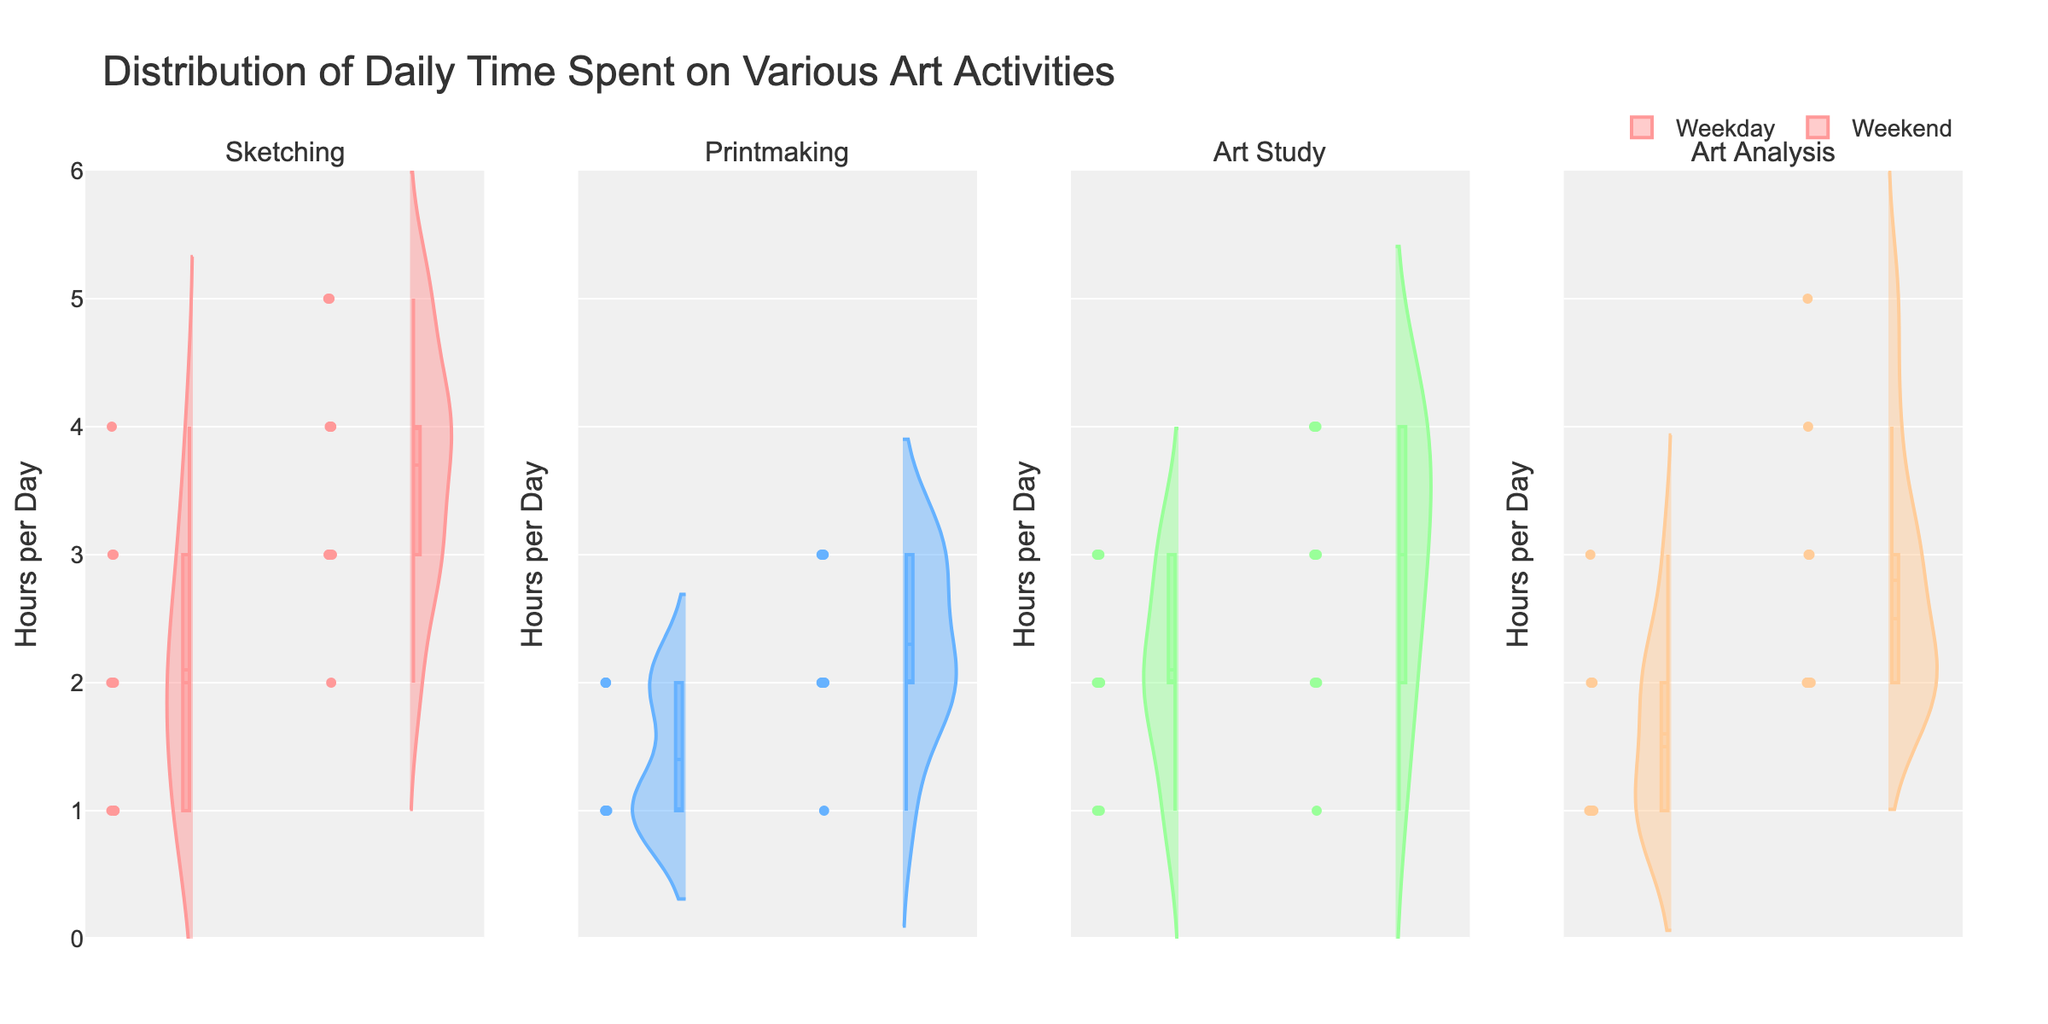whatisthetitleofthefigure The title is usually found at the top of the figure and it is clearly written in larger font.
Answer: Distribution of Daily Time Spent on Various Art Activities whichactivityhasthemostspreadinhoursonweekends To determine the spread, we look at the width of the violin plot. The wider it is, the more spread there is. Examining the violin plots, 'art_analysis' has the widest spread on weekends.
Answer: art analysis ontheweekdayswhichactivityhastheminimumvalueofhoursclosezero Look for the lowest point on the violin plots for each activity during the weekdays. 'art_analysis' shows a minimum close to zero hours.
Answer: art analysis whichactivityhasanoticeabledifferenceinmedianhoursbetweenweekdaysandweekends The median is indicated by a dashed line inside each violin plot. 'art_study' shows a noticeable difference between the weekday and weekend medians.
Answer: art study whatarethepossiblevaluesforthehoursperspentonsketchingduringweekdays The violin plot for 'sketching' on weekdays shows the spread of values. Based on the plot, the possible values range from 1 to 4 hours.
Answer: 1 to 4 hours howdothemedianhoursforsketchingduringweekdayscomparewiththeweekends Check the dashed line that represents the median for 'sketching' on both weekdays and weekends. Weekdays have a median around 2 hours, while weekends have a median around 4.
Answer: Weekends have a higher median howmanyhoursarecommonlyspentonprintmakingonweekends Observe the width and density of the violin plot for 'printmaking' on weekends. The densest region indicates common hours spent. The plot is densest around 2 and 3 hours.
Answer: 2 to 3 hours whichdaytypeshowsmorevariationinartstudyingactivities Look at the width of the 'art_study' violin plots for both weekdays and weekends. The wider the plot, the more variation exists. Weekends show more variation.
Answer: weekends whatdoeseachsideofaviolinplotrepresentinthefigure Each side of a violin plot represents the distribution of data for one category. In this figure, one side shows weekdays and the other shows weekends.
Answer: weekdays and weekends 